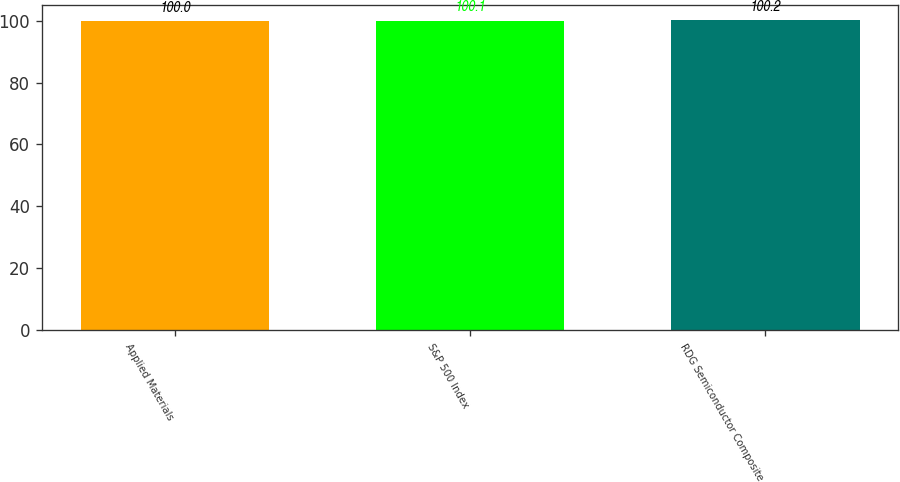Convert chart. <chart><loc_0><loc_0><loc_500><loc_500><bar_chart><fcel>Applied Materials<fcel>S&P 500 Index<fcel>RDG Semiconductor Composite<nl><fcel>100<fcel>100.1<fcel>100.2<nl></chart> 